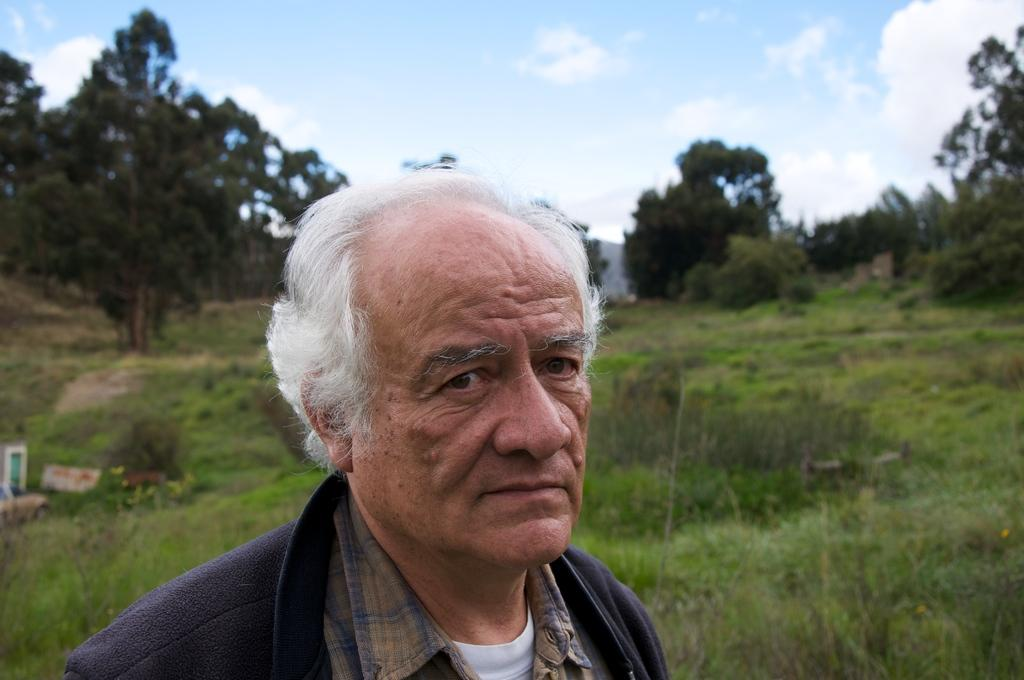Who or what is the main subject in the image? There is a person in the image. What can be seen in the background behind the person? There are trees visible behind the person. What other natural elements are present in the image? There are plants visible in the image. What part of the natural environment is visible in the image? The sky is visible in the image. How many basketballs can be seen floating in the water near the person? There are no basketballs or water visible in the image; it features a person with trees, plants, and the sky in the background. 